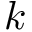Convert formula to latex. <formula><loc_0><loc_0><loc_500><loc_500>k</formula> 